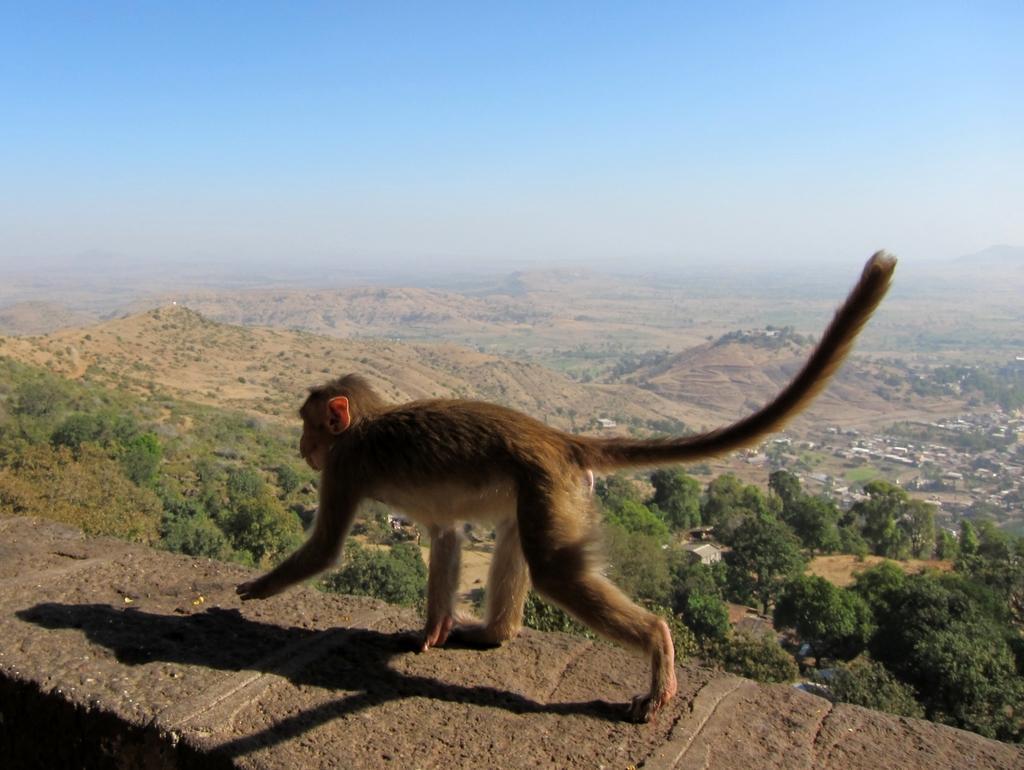Describe this image in one or two sentences. In this image there is a monkey walking on the rock surface, in the background of the image there are trees and mountains. 